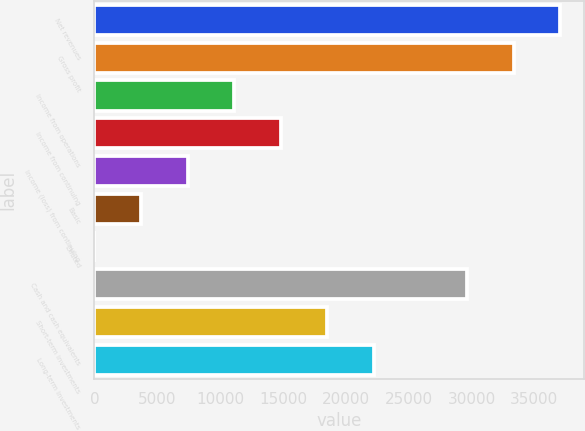<chart> <loc_0><loc_0><loc_500><loc_500><bar_chart><fcel>Net revenues<fcel>Gross profit<fcel>Income from operations<fcel>Income from continuing<fcel>Income (loss) from continuing<fcel>Basic<fcel>Diluted<fcel>Cash and cash equivalents<fcel>Short-term investments<fcel>Long-term investments<nl><fcel>37074<fcel>33366.7<fcel>11123.2<fcel>14830.5<fcel>7415.97<fcel>3708.72<fcel>1.47<fcel>29659.5<fcel>18537.7<fcel>22245<nl></chart> 